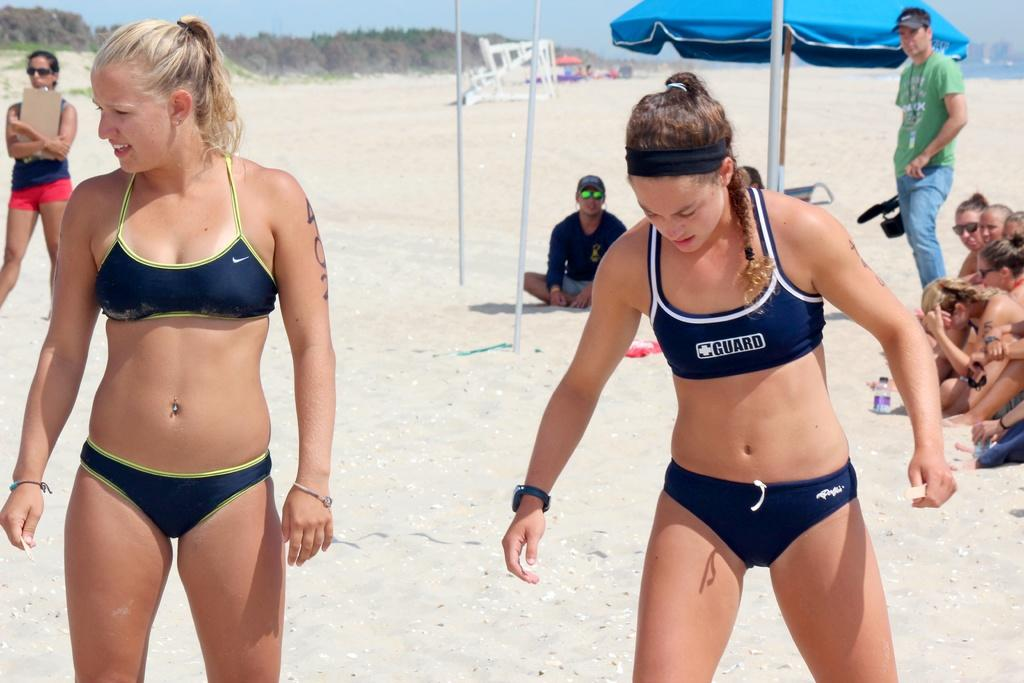<image>
Present a compact description of the photo's key features. Two young athletic girl, one with guard on her top is getting ready to play beach volleyball. 